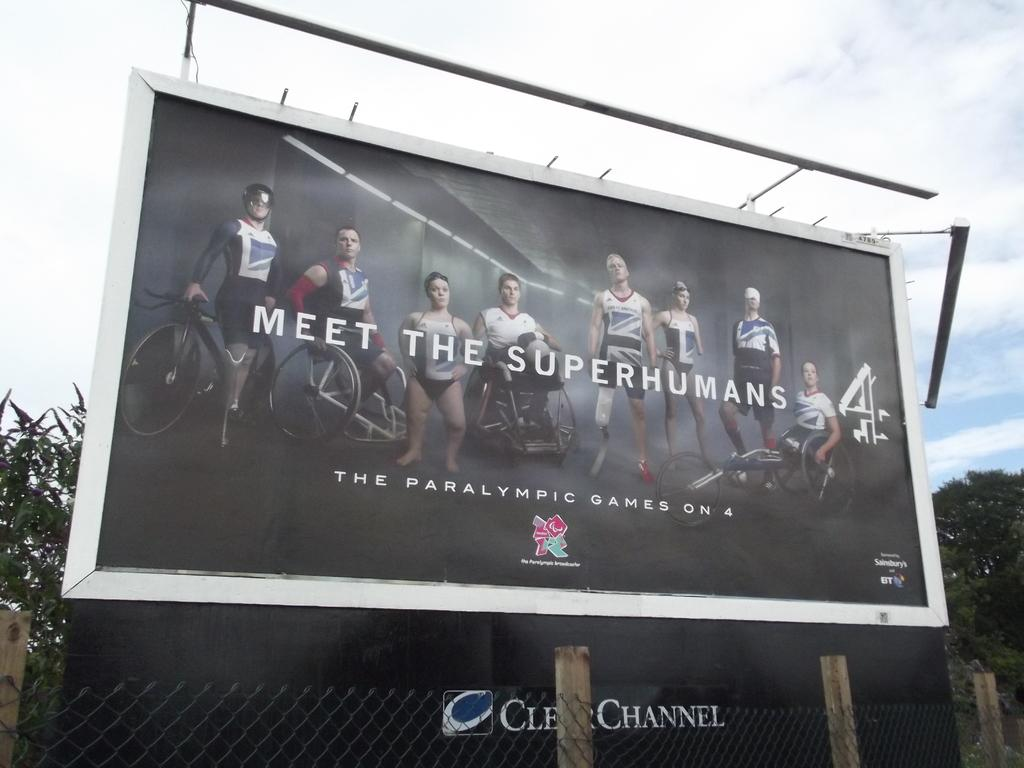<image>
Write a terse but informative summary of the picture. a billboard with Meet the Superhumans on it 